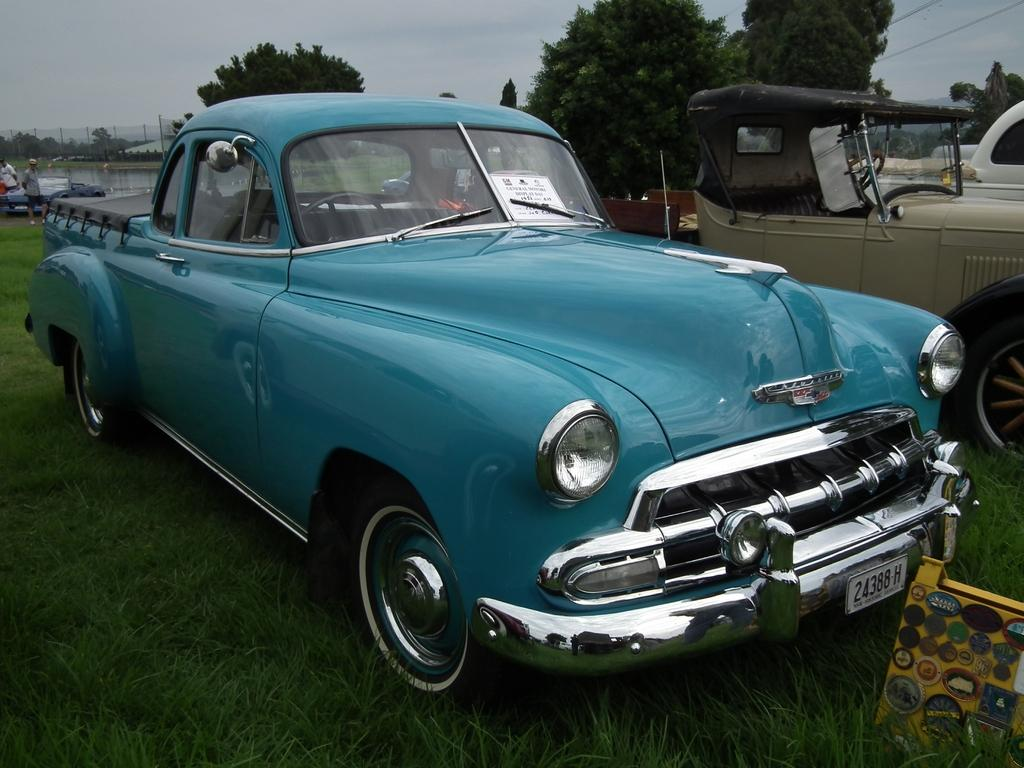What is the main subject of the image? There is a car in the center of the image. Where is the car located? The car is on a grassland. What else can be seen in the background of the image? There are other vehicles, people, trees, and poles in the background of the image. What type of knowledge is being shared among the people in the image? There is no indication in the image that people are sharing knowledge or engaging in any activity that would involve knowledge sharing. 